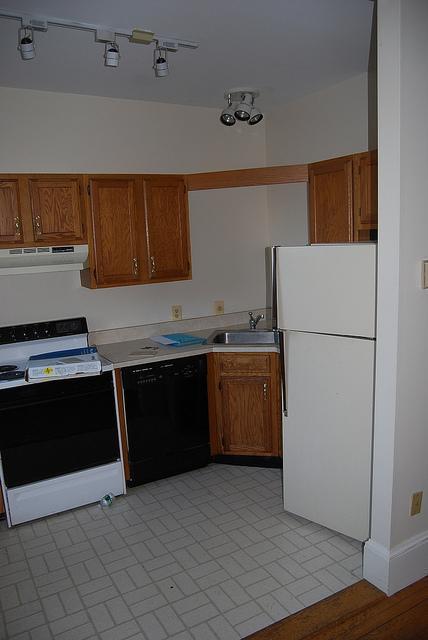What kind of cable is used in the lower right socket?
From the following set of four choices, select the accurate answer to respond to the question.
Options: Diamond, severed, coax, split. Coax. 